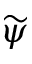Convert formula to latex. <formula><loc_0><loc_0><loc_500><loc_500>\widetilde { \psi }</formula> 